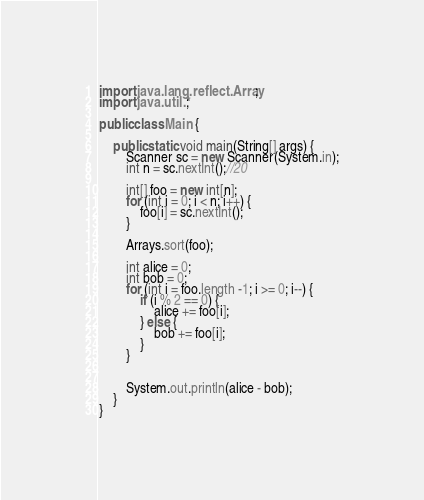<code> <loc_0><loc_0><loc_500><loc_500><_Java_>import java.lang.reflect.Array;
import java.util.*;

public class Main {

    public static void main(String[] args) {
        Scanner sc = new Scanner(System.in);
        int n = sc.nextInt();//20

        int[] foo = new int[n];
        for (int i = 0; i < n; i++) {
            foo[i] = sc.nextInt();
        }

        Arrays.sort(foo);

        int alice = 0;
        int bob = 0;
        for (int i = foo.length -1; i >= 0; i--) {
            if (i % 2 == 0) {
                alice += foo[i];
            } else {
                bob += foo[i];
            }
        }


        System.out.println(alice - bob);
    }
}
</code> 